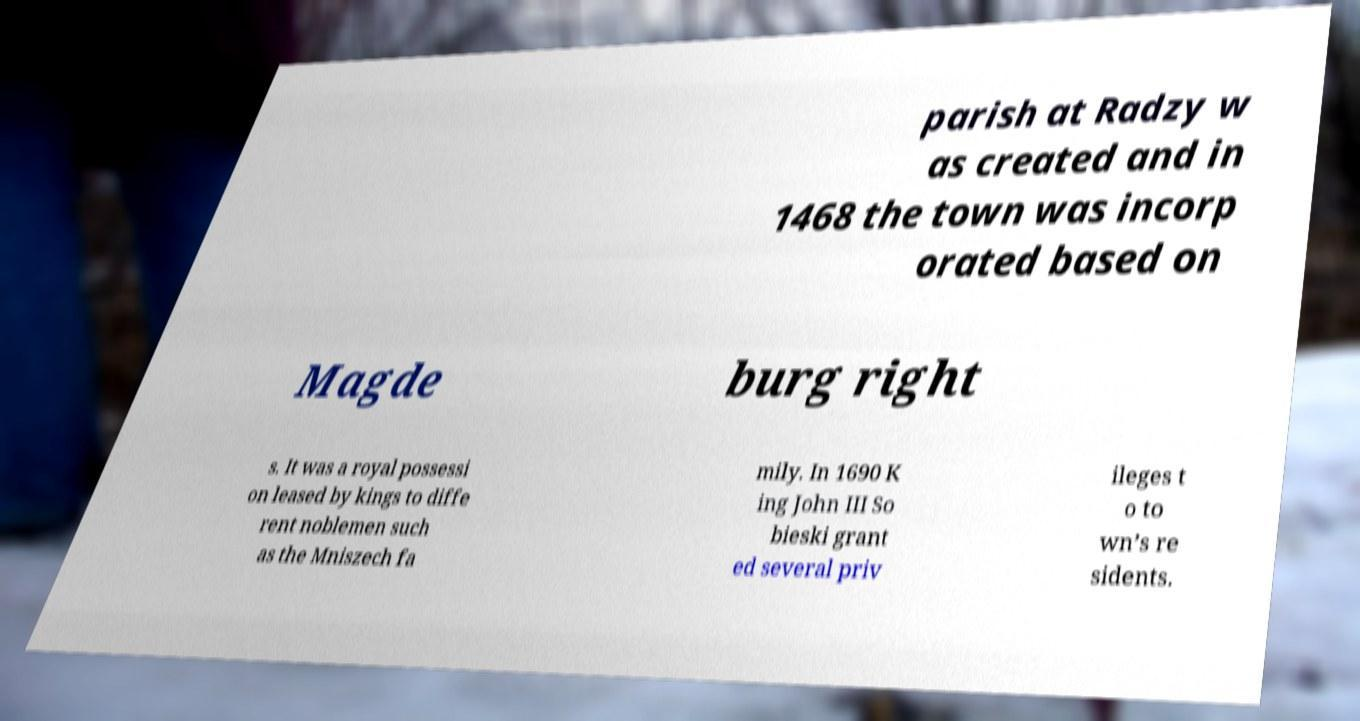Could you extract and type out the text from this image? parish at Radzy w as created and in 1468 the town was incorp orated based on Magde burg right s. It was a royal possessi on leased by kings to diffe rent noblemen such as the Mniszech fa mily. In 1690 K ing John III So bieski grant ed several priv ileges t o to wn’s re sidents. 